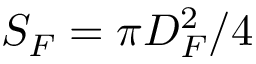Convert formula to latex. <formula><loc_0><loc_0><loc_500><loc_500>S _ { F } = \pi D _ { F } ^ { 2 } / 4</formula> 